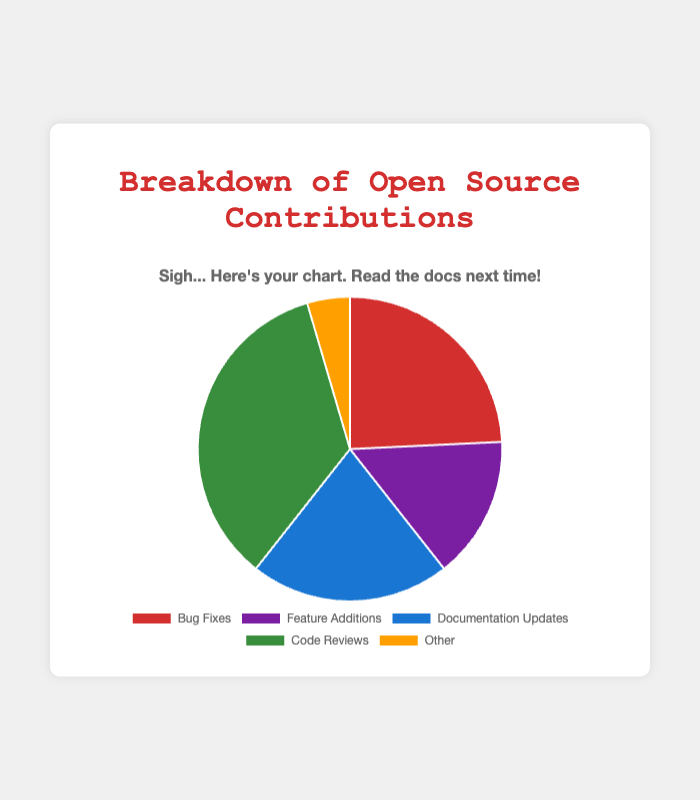What is the type of contribution with the highest count? Observing the pie chart, the segment for "Code Reviews" occupies the largest area, indicating the highest count. Specifically, combine the counts of users under "Code Reviews" which are Ivy (50) and Judy (65), summing up to 115.
Answer: Code Reviews Which contribution type has the smallest share on the pie chart? The smallest segment in the pie chart corresponds to the contribution type "Other," which sums up the contributions of Ken (10) and Leo (5). So, the total is 15. This is the lowest among the contribution types.
Answer: Other What is the total number of contributions for Bug Fixes? Adding the contributions from Alice (35), Bob (20), and Carol (25) gives 35 + 20 + 25 = 80.
Answer: 80 Is the total number of contributions for Feature Additions greater than for Documentation Updates? For Feature Additions, sum the contributions of Dave (15), Eve (25), and Frank (10): 15 + 25 + 10 = 50. For Documentation Updates, sum the contributions of Grace (40) and Heidi (30): 40 + 30 = 70. Comparing the totals, 50 is less than 70.
Answer: No Which contribution type has more contributions: Bug Fixes or Code Reviews? Summing the contributions for Bug Fixes: Alice (35) + Bob (20) + Carol (25) = 80. For Code Reviews: Ivy (50) + Judy (65) = 115. Code Reviews has more contributions.
Answer: Code Reviews How many more contributions are there in Code Reviews compared to Bug Fixes? Code Reviews total is 115, and Bug Fixes total is 80. The difference is 115 - 80 = 35.
Answer: 35 What percentage of the total contributions are Feature Additions? First, calculate the total contributions: Bug Fixes (80) + Feature Additions (50) + Documentation Updates (70) + Code Reviews (115) + Other (15) = 330. The percentage for Feature Additions is (50 / 330) * 100 ≈ 15.15%.
Answer: ~15.15% If Documentation Updates and Bug Fixes are combined, how would their total compare to Code Reviews? Combine Bug Fixes and Documentation Updates: 80 + 70 = 150. Code Reviews total is 115. 150 is greater than 115.
Answer: Greater 